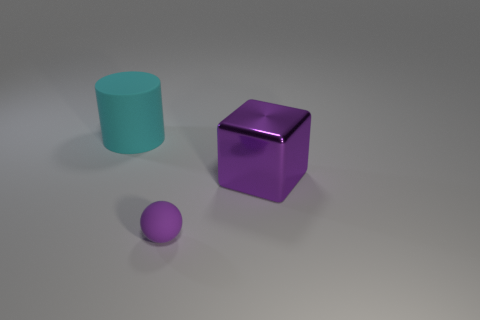Add 1 large cyan balls. How many objects exist? 4 Subtract all spheres. How many objects are left? 2 Add 2 tiny brown objects. How many tiny brown objects exist? 2 Subtract 0 green blocks. How many objects are left? 3 Subtract all large cyan rubber objects. Subtract all big rubber things. How many objects are left? 1 Add 2 cyan matte cylinders. How many cyan matte cylinders are left? 3 